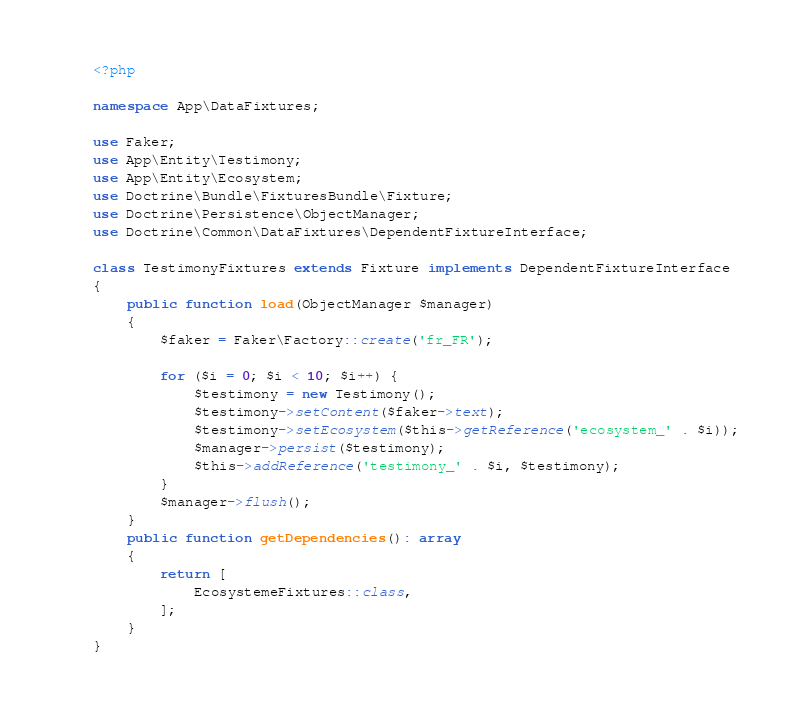Convert code to text. <code><loc_0><loc_0><loc_500><loc_500><_PHP_><?php

namespace App\DataFixtures;

use Faker;
use App\Entity\Testimony;
use App\Entity\Ecosystem;
use Doctrine\Bundle\FixturesBundle\Fixture;
use Doctrine\Persistence\ObjectManager;
use Doctrine\Common\DataFixtures\DependentFixtureInterface;

class TestimonyFixtures extends Fixture implements DependentFixtureInterface
{
    public function load(ObjectManager $manager)
    {
        $faker = Faker\Factory::create('fr_FR');

        for ($i = 0; $i < 10; $i++) {
            $testimony = new Testimony();
            $testimony->setContent($faker->text);
            $testimony->setEcosystem($this->getReference('ecosystem_' . $i));
            $manager->persist($testimony);
            $this->addReference('testimony_' . $i, $testimony);
        }
        $manager->flush();
    }
    public function getDependencies(): array
    {
        return [
            EcosystemeFixtures::class,
        ];
    }
}
</code> 